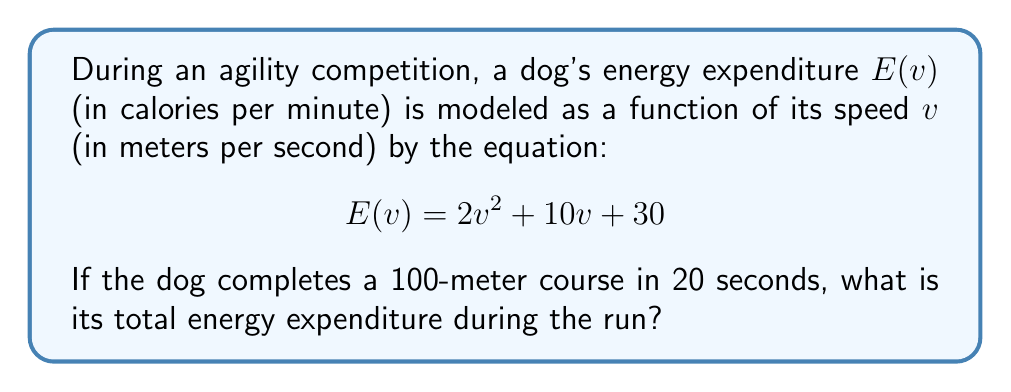Solve this math problem. To solve this problem, we need to follow these steps:

1) First, calculate the dog's average speed:
   Distance = 100 meters
   Time = 20 seconds
   Average speed = Distance / Time
   $v = 100 / 20 = 5$ m/s

2) Now that we know the speed, we can calculate the energy expenditure per minute:
   $E(5) = 2(5^2) + 10(5) + 30$
   $E(5) = 2(25) + 50 + 30$
   $E(5) = 50 + 50 + 30 = 130$ calories per minute

3) However, the dog didn't run for a full minute. We need to adjust for the actual time:
   Time of run = 20 seconds = 1/3 minute

4) Calculate the actual energy expenditure:
   Energy = (Energy per minute) * (Fraction of minute)
   $E = 130 * (1/3) = 43.33$ calories

Therefore, the dog's total energy expenditure during the 20-second run is approximately 43.33 calories.
Answer: $43.33$ calories 